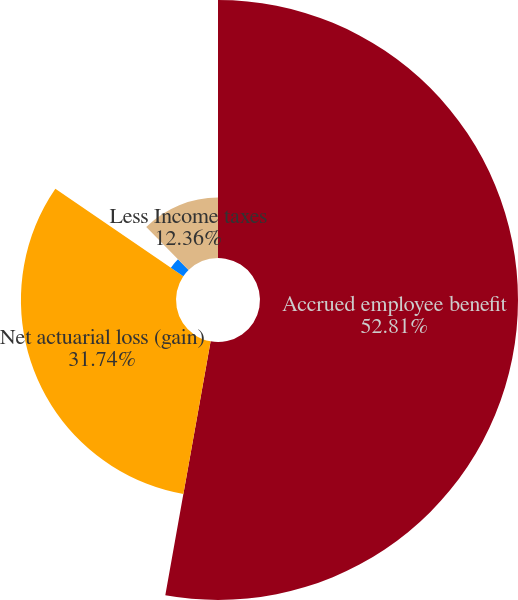Convert chart. <chart><loc_0><loc_0><loc_500><loc_500><pie_chart><fcel>Accrued employee benefit<fcel>Net actuarial loss (gain)<fcel>Prior service cost<fcel>Less Income taxes<nl><fcel>52.81%<fcel>31.74%<fcel>3.09%<fcel>12.36%<nl></chart> 